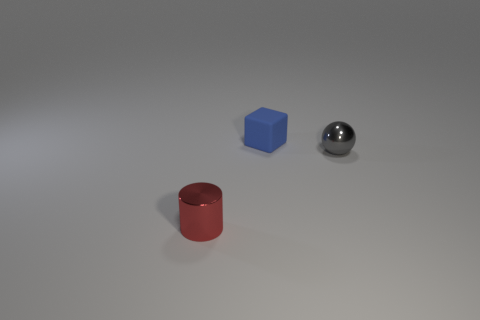What color is the small metal thing that is in front of the small shiny thing that is to the right of the small metallic object in front of the gray object?
Offer a terse response. Red. Are there any other things that are the same shape as the tiny blue rubber object?
Your answer should be very brief. No. Are there more blue matte cubes than purple rubber cubes?
Provide a short and direct response. Yes. What number of things are both to the left of the small gray sphere and on the right side of the blue matte object?
Your answer should be compact. 0. There is a small metallic object that is to the left of the tiny blue cube; what number of red metallic cylinders are right of it?
Keep it short and to the point. 0. Do the metallic object to the right of the tiny metal cylinder and the metallic object left of the small gray metallic object have the same size?
Provide a short and direct response. Yes. What number of small yellow shiny blocks are there?
Offer a terse response. 0. How many gray objects are the same material as the cylinder?
Provide a succinct answer. 1. Are there an equal number of tiny cubes on the right side of the small blue block and purple metallic objects?
Provide a succinct answer. Yes. There is a metallic sphere; is it the same size as the shiny thing left of the blue rubber block?
Your answer should be compact. Yes. 